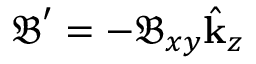Convert formula to latex. <formula><loc_0><loc_0><loc_500><loc_500>\mathfrak { B } ^ { \prime } = - \mathfrak { B } _ { x y } \hat { k } _ { z }</formula> 